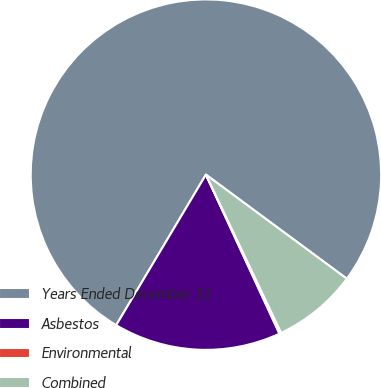Convert chart to OTSL. <chart><loc_0><loc_0><loc_500><loc_500><pie_chart><fcel>Years Ended December 31<fcel>Asbestos<fcel>Environmental<fcel>Combined<nl><fcel>76.58%<fcel>15.45%<fcel>0.17%<fcel>7.81%<nl></chart> 